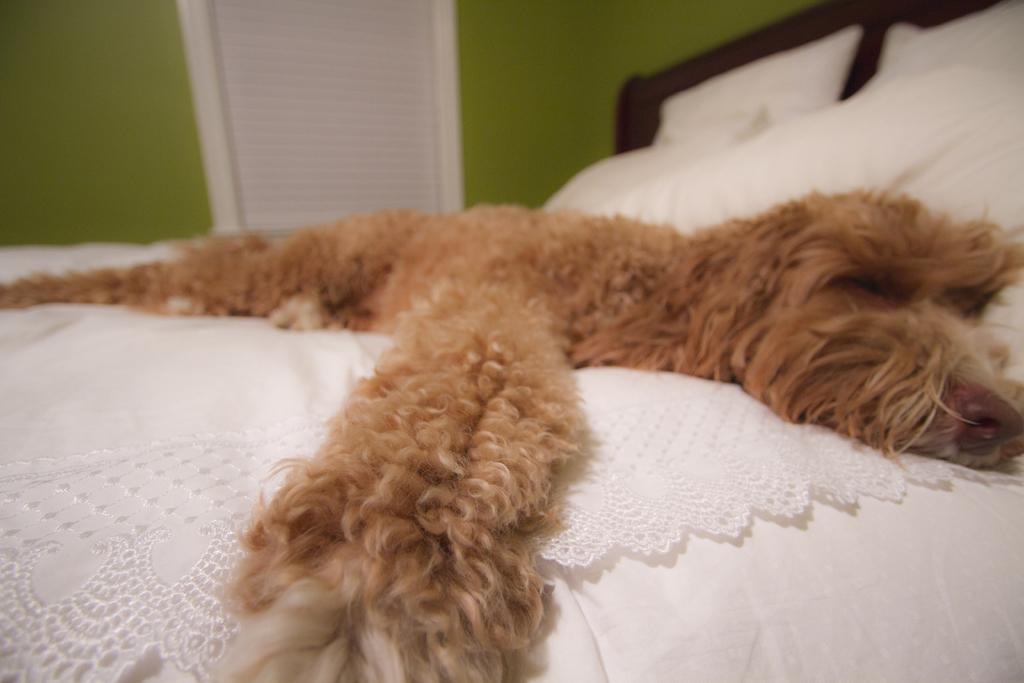What type of animal is present in the image? There is a dog in the image. What is the dog doing in the image? The dog is laying on a bed. What color is the wall in the image? The wall is green. Can you see any openings in the room? Yes, there is a window in the image. What is the name of the servant in the image? There is no servant present in the image. What type of sheet is covering the dog? There is no sheet mentioned or visible in the image. 